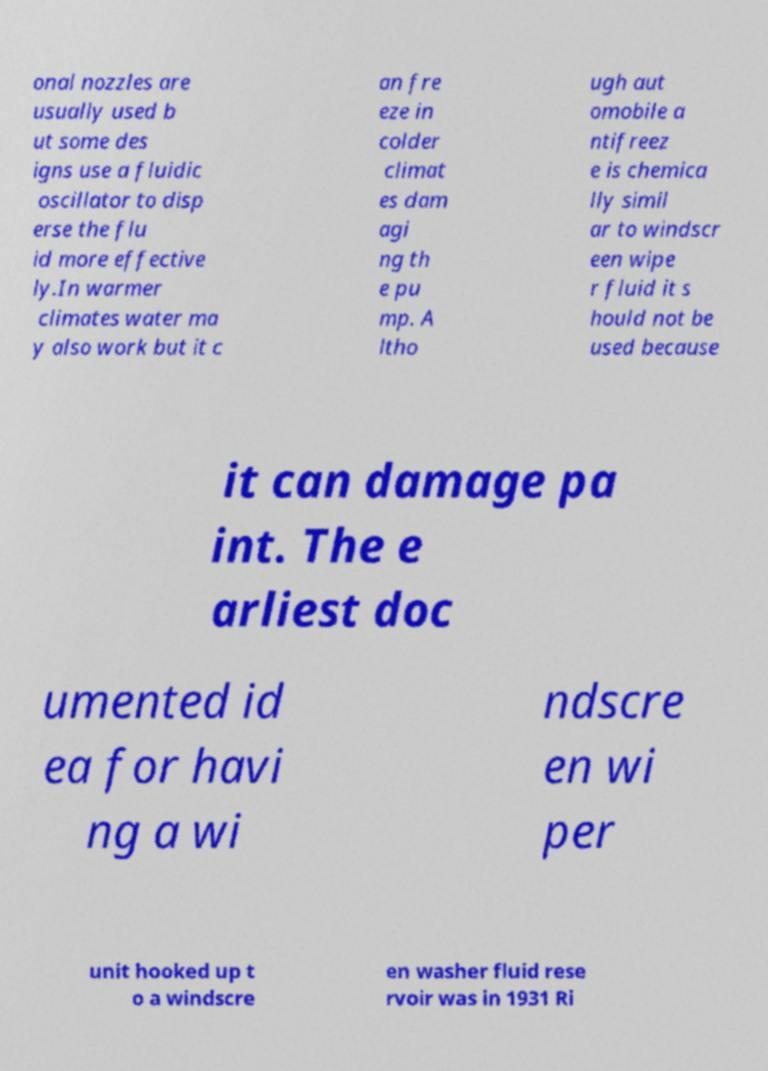Could you extract and type out the text from this image? onal nozzles are usually used b ut some des igns use a fluidic oscillator to disp erse the flu id more effective ly.In warmer climates water ma y also work but it c an fre eze in colder climat es dam agi ng th e pu mp. A ltho ugh aut omobile a ntifreez e is chemica lly simil ar to windscr een wipe r fluid it s hould not be used because it can damage pa int. The e arliest doc umented id ea for havi ng a wi ndscre en wi per unit hooked up t o a windscre en washer fluid rese rvoir was in 1931 Ri 